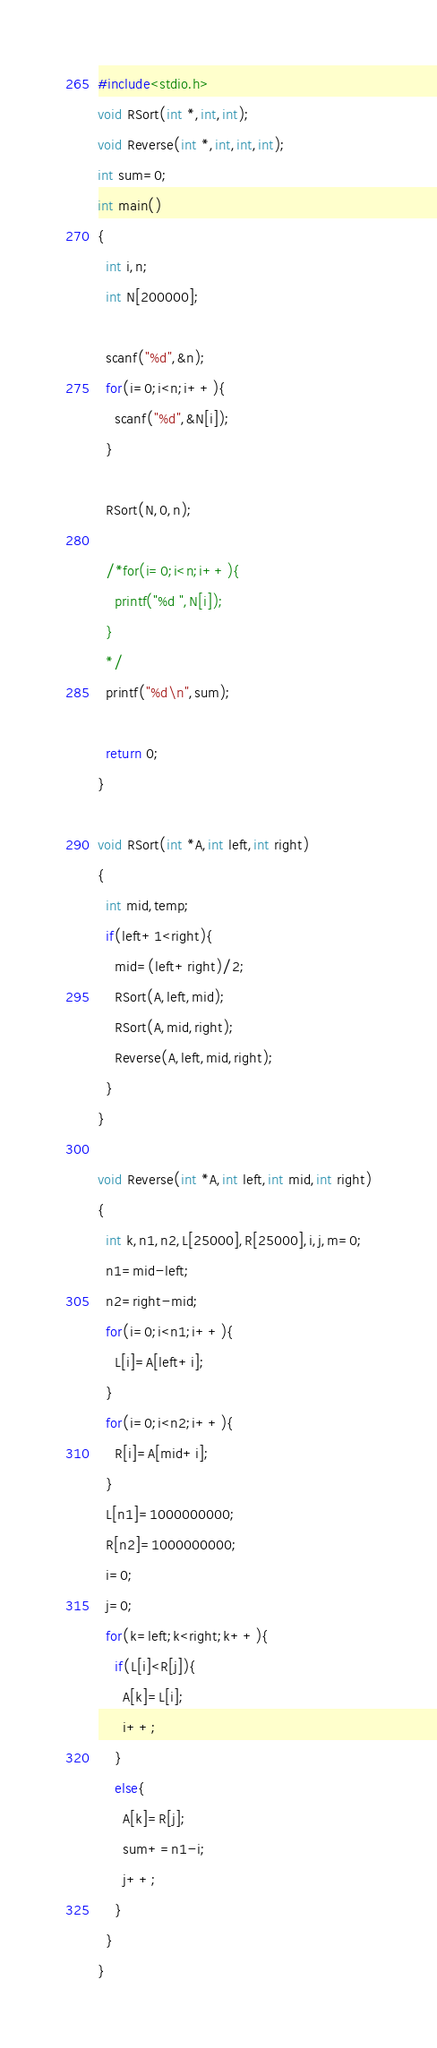Convert code to text. <code><loc_0><loc_0><loc_500><loc_500><_C_>#include<stdio.h>
void RSort(int *,int,int);
void Reverse(int *,int,int,int);
int sum=0;
int main()
{
  int i,n;
  int N[200000];
  
  scanf("%d",&n);
  for(i=0;i<n;i++){
    scanf("%d",&N[i]);
  }

  RSort(N,0,n);

  /*for(i=0;i<n;i++){
    printf("%d ",N[i]);
  }
  */
  printf("%d\n",sum);

  return 0;
}

void RSort(int *A,int left,int right)
{
  int mid,temp;
  if(left+1<right){
    mid=(left+right)/2;
    RSort(A,left,mid);
    RSort(A,mid,right);
    Reverse(A,left,mid,right);
  }
}

void Reverse(int *A,int left,int mid,int right)
{
  int k,n1,n2,L[25000],R[25000],i,j,m=0;
  n1=mid-left;
  n2=right-mid;
  for(i=0;i<n1;i++){
    L[i]=A[left+i];
  }
  for(i=0;i<n2;i++){
    R[i]=A[mid+i];
  }
  L[n1]=1000000000;
  R[n2]=1000000000;
  i=0;
  j=0;
  for(k=left;k<right;k++){
    if(L[i]<R[j]){
      A[k]=L[i];
      i++;
    }
    else{
      A[k]=R[j];
      sum+=n1-i;
      j++;
    }
  }
}</code> 